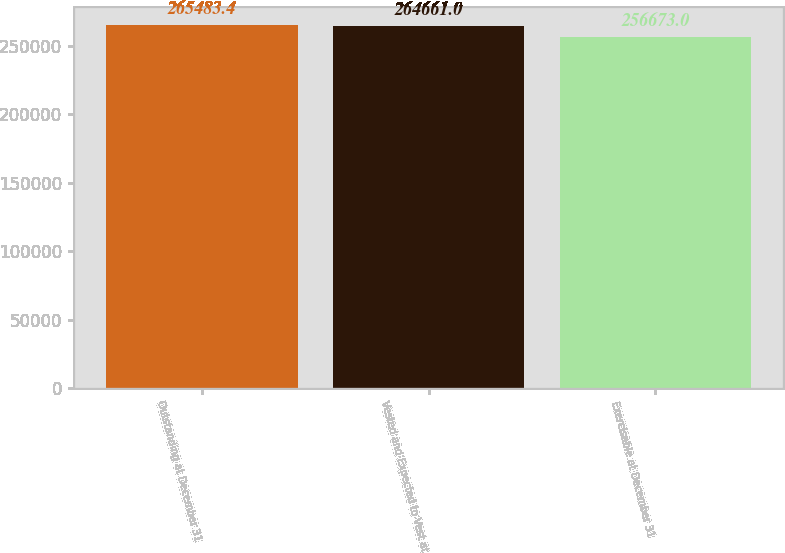<chart> <loc_0><loc_0><loc_500><loc_500><bar_chart><fcel>Outstanding at December 31<fcel>Vested and Expected to Vest at<fcel>Exercisable at December 31<nl><fcel>265483<fcel>264661<fcel>256673<nl></chart> 